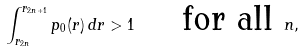Convert formula to latex. <formula><loc_0><loc_0><loc_500><loc_500>\int _ { r _ { 2 n } } ^ { r _ { 2 n + 1 } } p _ { 0 } ( r ) \, d r > 1 \quad \text { for all } n ,</formula> 